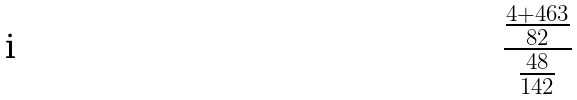<formula> <loc_0><loc_0><loc_500><loc_500>\frac { \frac { 4 + 4 6 3 } { 8 2 } } { \frac { 4 8 } { 1 4 2 } }</formula> 